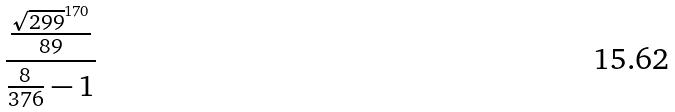<formula> <loc_0><loc_0><loc_500><loc_500>\frac { \frac { \sqrt { 2 9 9 } ^ { 1 7 0 } } { 8 9 } } { \frac { 8 } { 3 7 6 } - 1 }</formula> 